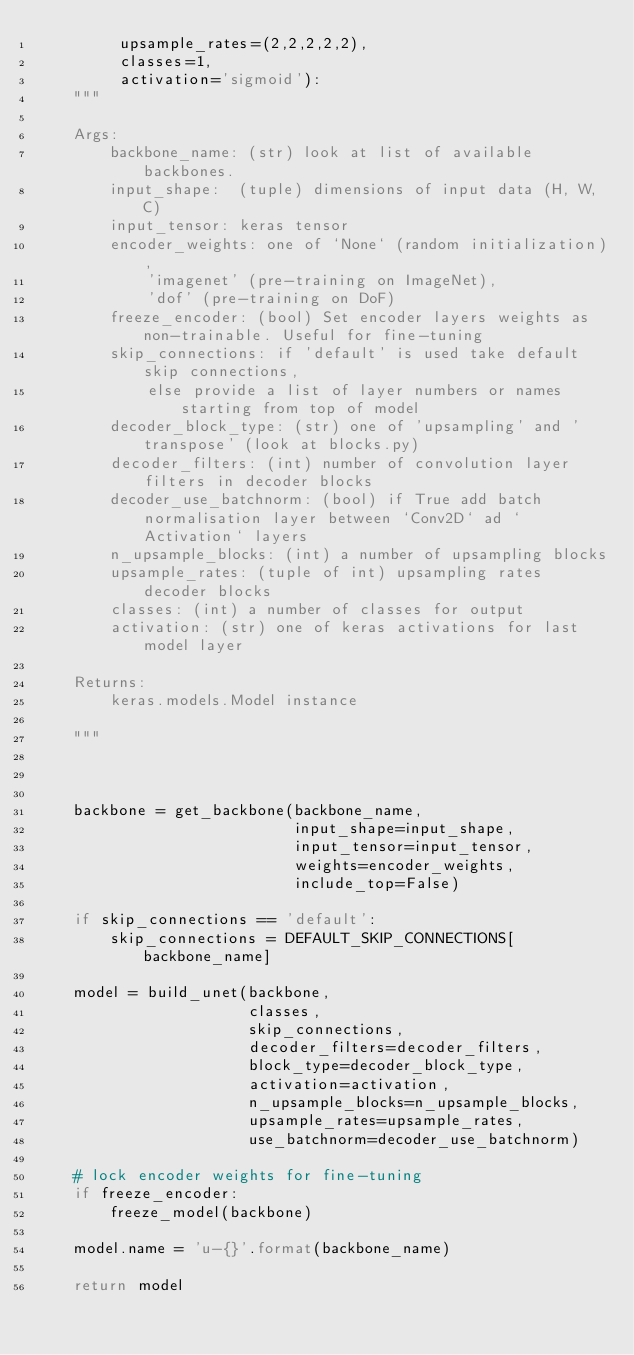Convert code to text. <code><loc_0><loc_0><loc_500><loc_500><_Python_>         upsample_rates=(2,2,2,2,2),
         classes=1,
         activation='sigmoid'):
    """

    Args:
        backbone_name: (str) look at list of available backbones.
        input_shape:  (tuple) dimensions of input data (H, W, C)
        input_tensor: keras tensor
        encoder_weights: one of `None` (random initialization), 
            'imagenet' (pre-training on ImageNet), 
            'dof' (pre-training on DoF)
        freeze_encoder: (bool) Set encoder layers weights as non-trainable. Useful for fine-tuning
        skip_connections: if 'default' is used take default skip connections,
            else provide a list of layer numbers or names starting from top of model
        decoder_block_type: (str) one of 'upsampling' and 'transpose' (look at blocks.py)
        decoder_filters: (int) number of convolution layer filters in decoder blocks
        decoder_use_batchnorm: (bool) if True add batch normalisation layer between `Conv2D` ad `Activation` layers
        n_upsample_blocks: (int) a number of upsampling blocks
        upsample_rates: (tuple of int) upsampling rates decoder blocks
        classes: (int) a number of classes for output
        activation: (str) one of keras activations for last model layer

    Returns:
        keras.models.Model instance

    """



    backbone = get_backbone(backbone_name,
                            input_shape=input_shape,
                            input_tensor=input_tensor,
                            weights=encoder_weights,
                            include_top=False)

    if skip_connections == 'default':
        skip_connections = DEFAULT_SKIP_CONNECTIONS[backbone_name]

    model = build_unet(backbone,
                       classes,
                       skip_connections,
                       decoder_filters=decoder_filters,
                       block_type=decoder_block_type,
                       activation=activation,
                       n_upsample_blocks=n_upsample_blocks,
                       upsample_rates=upsample_rates,
                       use_batchnorm=decoder_use_batchnorm)

    # lock encoder weights for fine-tuning
    if freeze_encoder:
        freeze_model(backbone)

    model.name = 'u-{}'.format(backbone_name)

    return model
</code> 